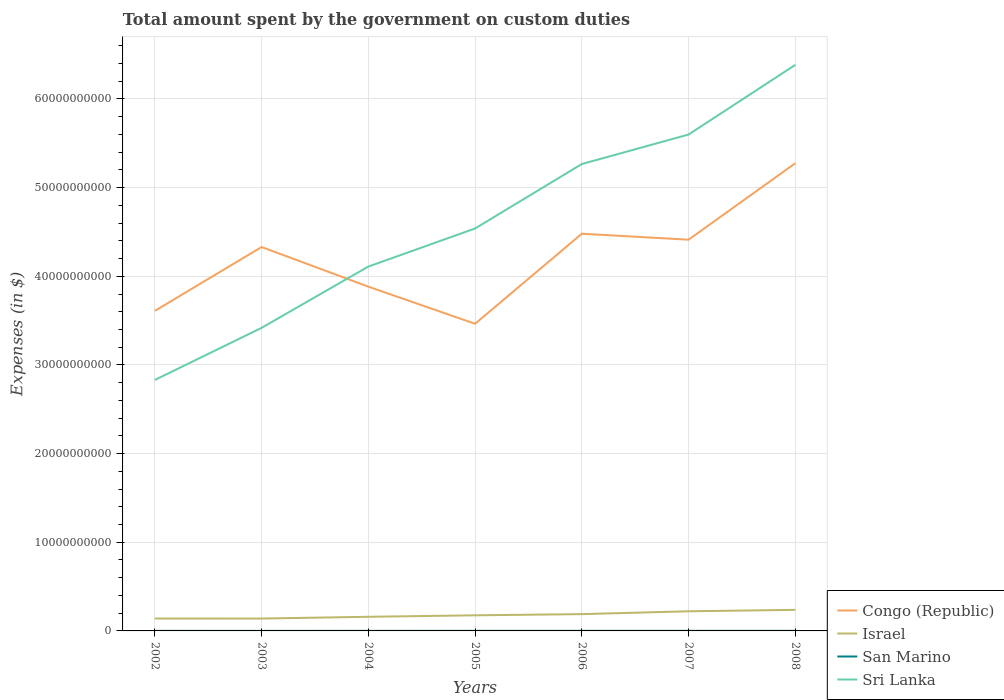How many different coloured lines are there?
Offer a terse response. 4. Across all years, what is the maximum amount spent on custom duties by the government in Israel?
Give a very brief answer. 1.39e+09. What is the total amount spent on custom duties by the government in San Marino in the graph?
Provide a short and direct response. -5.59e+05. What is the difference between the highest and the second highest amount spent on custom duties by the government in San Marino?
Your answer should be compact. 6.27e+06. Is the amount spent on custom duties by the government in San Marino strictly greater than the amount spent on custom duties by the government in Sri Lanka over the years?
Keep it short and to the point. Yes. How many years are there in the graph?
Offer a very short reply. 7. What is the difference between two consecutive major ticks on the Y-axis?
Provide a short and direct response. 1.00e+1. How are the legend labels stacked?
Provide a short and direct response. Vertical. What is the title of the graph?
Provide a succinct answer. Total amount spent by the government on custom duties. Does "Macedonia" appear as one of the legend labels in the graph?
Your response must be concise. No. What is the label or title of the Y-axis?
Provide a short and direct response. Expenses (in $). What is the Expenses (in $) of Congo (Republic) in 2002?
Ensure brevity in your answer.  3.61e+1. What is the Expenses (in $) of Israel in 2002?
Your answer should be very brief. 1.40e+09. What is the Expenses (in $) in San Marino in 2002?
Offer a very short reply. 4.43e+06. What is the Expenses (in $) in Sri Lanka in 2002?
Keep it short and to the point. 2.83e+1. What is the Expenses (in $) of Congo (Republic) in 2003?
Offer a terse response. 4.33e+1. What is the Expenses (in $) in Israel in 2003?
Give a very brief answer. 1.39e+09. What is the Expenses (in $) in San Marino in 2003?
Your response must be concise. 3.79e+06. What is the Expenses (in $) of Sri Lanka in 2003?
Keep it short and to the point. 3.42e+1. What is the Expenses (in $) of Congo (Republic) in 2004?
Make the answer very short. 3.88e+1. What is the Expenses (in $) of Israel in 2004?
Provide a succinct answer. 1.59e+09. What is the Expenses (in $) of San Marino in 2004?
Ensure brevity in your answer.  5.95e+06. What is the Expenses (in $) in Sri Lanka in 2004?
Provide a short and direct response. 4.11e+1. What is the Expenses (in $) in Congo (Republic) in 2005?
Your answer should be compact. 3.46e+1. What is the Expenses (in $) in Israel in 2005?
Offer a terse response. 1.76e+09. What is the Expenses (in $) in San Marino in 2005?
Offer a very short reply. 8.54e+06. What is the Expenses (in $) of Sri Lanka in 2005?
Offer a very short reply. 4.54e+1. What is the Expenses (in $) of Congo (Republic) in 2006?
Provide a succinct answer. 4.48e+1. What is the Expenses (in $) in Israel in 2006?
Make the answer very short. 1.89e+09. What is the Expenses (in $) in San Marino in 2006?
Your response must be concise. 1.01e+07. What is the Expenses (in $) in Sri Lanka in 2006?
Provide a short and direct response. 5.27e+1. What is the Expenses (in $) of Congo (Republic) in 2007?
Offer a terse response. 4.41e+1. What is the Expenses (in $) of Israel in 2007?
Your answer should be very brief. 2.22e+09. What is the Expenses (in $) of San Marino in 2007?
Provide a short and direct response. 9.10e+06. What is the Expenses (in $) of Sri Lanka in 2007?
Your answer should be very brief. 5.60e+1. What is the Expenses (in $) in Congo (Republic) in 2008?
Offer a terse response. 5.27e+1. What is the Expenses (in $) in Israel in 2008?
Give a very brief answer. 2.38e+09. What is the Expenses (in $) in San Marino in 2008?
Ensure brevity in your answer.  9.16e+06. What is the Expenses (in $) in Sri Lanka in 2008?
Give a very brief answer. 6.38e+1. Across all years, what is the maximum Expenses (in $) in Congo (Republic)?
Your answer should be very brief. 5.27e+1. Across all years, what is the maximum Expenses (in $) in Israel?
Make the answer very short. 2.38e+09. Across all years, what is the maximum Expenses (in $) in San Marino?
Provide a short and direct response. 1.01e+07. Across all years, what is the maximum Expenses (in $) of Sri Lanka?
Offer a very short reply. 6.38e+1. Across all years, what is the minimum Expenses (in $) in Congo (Republic)?
Your response must be concise. 3.46e+1. Across all years, what is the minimum Expenses (in $) in Israel?
Offer a very short reply. 1.39e+09. Across all years, what is the minimum Expenses (in $) of San Marino?
Your answer should be very brief. 3.79e+06. Across all years, what is the minimum Expenses (in $) of Sri Lanka?
Ensure brevity in your answer.  2.83e+1. What is the total Expenses (in $) in Congo (Republic) in the graph?
Make the answer very short. 2.95e+11. What is the total Expenses (in $) of Israel in the graph?
Offer a terse response. 1.26e+1. What is the total Expenses (in $) of San Marino in the graph?
Offer a terse response. 5.10e+07. What is the total Expenses (in $) in Sri Lanka in the graph?
Offer a very short reply. 3.21e+11. What is the difference between the Expenses (in $) in Congo (Republic) in 2002 and that in 2003?
Your response must be concise. -7.20e+09. What is the difference between the Expenses (in $) of San Marino in 2002 and that in 2003?
Give a very brief answer. 6.50e+05. What is the difference between the Expenses (in $) of Sri Lanka in 2002 and that in 2003?
Keep it short and to the point. -5.88e+09. What is the difference between the Expenses (in $) of Congo (Republic) in 2002 and that in 2004?
Keep it short and to the point. -2.73e+09. What is the difference between the Expenses (in $) in Israel in 2002 and that in 2004?
Ensure brevity in your answer.  -1.96e+08. What is the difference between the Expenses (in $) of San Marino in 2002 and that in 2004?
Make the answer very short. -1.52e+06. What is the difference between the Expenses (in $) of Sri Lanka in 2002 and that in 2004?
Your response must be concise. -1.28e+1. What is the difference between the Expenses (in $) in Congo (Republic) in 2002 and that in 2005?
Your answer should be very brief. 1.46e+09. What is the difference between the Expenses (in $) of Israel in 2002 and that in 2005?
Ensure brevity in your answer.  -3.63e+08. What is the difference between the Expenses (in $) of San Marino in 2002 and that in 2005?
Your response must be concise. -4.10e+06. What is the difference between the Expenses (in $) in Sri Lanka in 2002 and that in 2005?
Make the answer very short. -1.71e+1. What is the difference between the Expenses (in $) of Congo (Republic) in 2002 and that in 2006?
Offer a very short reply. -8.70e+09. What is the difference between the Expenses (in $) of Israel in 2002 and that in 2006?
Provide a succinct answer. -4.96e+08. What is the difference between the Expenses (in $) of San Marino in 2002 and that in 2006?
Provide a short and direct response. -5.62e+06. What is the difference between the Expenses (in $) in Sri Lanka in 2002 and that in 2006?
Give a very brief answer. -2.44e+1. What is the difference between the Expenses (in $) in Congo (Republic) in 2002 and that in 2007?
Your answer should be very brief. -8.03e+09. What is the difference between the Expenses (in $) in Israel in 2002 and that in 2007?
Your answer should be compact. -8.17e+08. What is the difference between the Expenses (in $) in San Marino in 2002 and that in 2007?
Make the answer very short. -4.66e+06. What is the difference between the Expenses (in $) of Sri Lanka in 2002 and that in 2007?
Give a very brief answer. -2.77e+1. What is the difference between the Expenses (in $) in Congo (Republic) in 2002 and that in 2008?
Keep it short and to the point. -1.66e+1. What is the difference between the Expenses (in $) of Israel in 2002 and that in 2008?
Your answer should be very brief. -9.77e+08. What is the difference between the Expenses (in $) in San Marino in 2002 and that in 2008?
Give a very brief answer. -4.73e+06. What is the difference between the Expenses (in $) in Sri Lanka in 2002 and that in 2008?
Offer a very short reply. -3.55e+1. What is the difference between the Expenses (in $) of Congo (Republic) in 2003 and that in 2004?
Your answer should be very brief. 4.47e+09. What is the difference between the Expenses (in $) of Israel in 2003 and that in 2004?
Your response must be concise. -2.00e+08. What is the difference between the Expenses (in $) of San Marino in 2003 and that in 2004?
Ensure brevity in your answer.  -2.17e+06. What is the difference between the Expenses (in $) of Sri Lanka in 2003 and that in 2004?
Make the answer very short. -6.91e+09. What is the difference between the Expenses (in $) in Congo (Republic) in 2003 and that in 2005?
Provide a succinct answer. 8.66e+09. What is the difference between the Expenses (in $) of Israel in 2003 and that in 2005?
Your answer should be compact. -3.67e+08. What is the difference between the Expenses (in $) in San Marino in 2003 and that in 2005?
Ensure brevity in your answer.  -4.75e+06. What is the difference between the Expenses (in $) in Sri Lanka in 2003 and that in 2005?
Your answer should be very brief. -1.12e+1. What is the difference between the Expenses (in $) of Congo (Republic) in 2003 and that in 2006?
Provide a short and direct response. -1.50e+09. What is the difference between the Expenses (in $) in Israel in 2003 and that in 2006?
Provide a succinct answer. -5.00e+08. What is the difference between the Expenses (in $) of San Marino in 2003 and that in 2006?
Give a very brief answer. -6.27e+06. What is the difference between the Expenses (in $) of Sri Lanka in 2003 and that in 2006?
Make the answer very short. -1.85e+1. What is the difference between the Expenses (in $) in Congo (Republic) in 2003 and that in 2007?
Provide a short and direct response. -8.27e+08. What is the difference between the Expenses (in $) of Israel in 2003 and that in 2007?
Provide a short and direct response. -8.21e+08. What is the difference between the Expenses (in $) of San Marino in 2003 and that in 2007?
Your response must be concise. -5.31e+06. What is the difference between the Expenses (in $) in Sri Lanka in 2003 and that in 2007?
Ensure brevity in your answer.  -2.18e+1. What is the difference between the Expenses (in $) of Congo (Republic) in 2003 and that in 2008?
Your answer should be compact. -9.45e+09. What is the difference between the Expenses (in $) of Israel in 2003 and that in 2008?
Provide a short and direct response. -9.81e+08. What is the difference between the Expenses (in $) of San Marino in 2003 and that in 2008?
Offer a very short reply. -5.38e+06. What is the difference between the Expenses (in $) of Sri Lanka in 2003 and that in 2008?
Your response must be concise. -2.97e+1. What is the difference between the Expenses (in $) in Congo (Republic) in 2004 and that in 2005?
Your answer should be compact. 4.19e+09. What is the difference between the Expenses (in $) of Israel in 2004 and that in 2005?
Keep it short and to the point. -1.67e+08. What is the difference between the Expenses (in $) of San Marino in 2004 and that in 2005?
Make the answer very short. -2.58e+06. What is the difference between the Expenses (in $) in Sri Lanka in 2004 and that in 2005?
Give a very brief answer. -4.29e+09. What is the difference between the Expenses (in $) in Congo (Republic) in 2004 and that in 2006?
Provide a succinct answer. -5.97e+09. What is the difference between the Expenses (in $) in Israel in 2004 and that in 2006?
Make the answer very short. -3.00e+08. What is the difference between the Expenses (in $) in San Marino in 2004 and that in 2006?
Give a very brief answer. -4.10e+06. What is the difference between the Expenses (in $) in Sri Lanka in 2004 and that in 2006?
Provide a succinct answer. -1.16e+1. What is the difference between the Expenses (in $) of Congo (Republic) in 2004 and that in 2007?
Make the answer very short. -5.30e+09. What is the difference between the Expenses (in $) in Israel in 2004 and that in 2007?
Keep it short and to the point. -6.21e+08. What is the difference between the Expenses (in $) in San Marino in 2004 and that in 2007?
Your answer should be very brief. -3.14e+06. What is the difference between the Expenses (in $) of Sri Lanka in 2004 and that in 2007?
Your answer should be compact. -1.49e+1. What is the difference between the Expenses (in $) in Congo (Republic) in 2004 and that in 2008?
Offer a very short reply. -1.39e+1. What is the difference between the Expenses (in $) of Israel in 2004 and that in 2008?
Give a very brief answer. -7.81e+08. What is the difference between the Expenses (in $) of San Marino in 2004 and that in 2008?
Keep it short and to the point. -3.21e+06. What is the difference between the Expenses (in $) in Sri Lanka in 2004 and that in 2008?
Provide a short and direct response. -2.27e+1. What is the difference between the Expenses (in $) in Congo (Republic) in 2005 and that in 2006?
Your answer should be compact. -1.02e+1. What is the difference between the Expenses (in $) in Israel in 2005 and that in 2006?
Provide a short and direct response. -1.33e+08. What is the difference between the Expenses (in $) in San Marino in 2005 and that in 2006?
Make the answer very short. -1.51e+06. What is the difference between the Expenses (in $) in Sri Lanka in 2005 and that in 2006?
Offer a very short reply. -7.27e+09. What is the difference between the Expenses (in $) of Congo (Republic) in 2005 and that in 2007?
Your answer should be very brief. -9.48e+09. What is the difference between the Expenses (in $) in Israel in 2005 and that in 2007?
Give a very brief answer. -4.54e+08. What is the difference between the Expenses (in $) of San Marino in 2005 and that in 2007?
Your answer should be compact. -5.59e+05. What is the difference between the Expenses (in $) of Sri Lanka in 2005 and that in 2007?
Offer a very short reply. -1.06e+1. What is the difference between the Expenses (in $) of Congo (Republic) in 2005 and that in 2008?
Give a very brief answer. -1.81e+1. What is the difference between the Expenses (in $) in Israel in 2005 and that in 2008?
Your response must be concise. -6.14e+08. What is the difference between the Expenses (in $) in San Marino in 2005 and that in 2008?
Your answer should be compact. -6.25e+05. What is the difference between the Expenses (in $) in Sri Lanka in 2005 and that in 2008?
Offer a very short reply. -1.85e+1. What is the difference between the Expenses (in $) in Congo (Republic) in 2006 and that in 2007?
Keep it short and to the point. 6.73e+08. What is the difference between the Expenses (in $) of Israel in 2006 and that in 2007?
Keep it short and to the point. -3.21e+08. What is the difference between the Expenses (in $) in San Marino in 2006 and that in 2007?
Your answer should be compact. 9.55e+05. What is the difference between the Expenses (in $) of Sri Lanka in 2006 and that in 2007?
Keep it short and to the point. -3.33e+09. What is the difference between the Expenses (in $) in Congo (Republic) in 2006 and that in 2008?
Your response must be concise. -7.95e+09. What is the difference between the Expenses (in $) of Israel in 2006 and that in 2008?
Provide a short and direct response. -4.81e+08. What is the difference between the Expenses (in $) in San Marino in 2006 and that in 2008?
Make the answer very short. 8.89e+05. What is the difference between the Expenses (in $) of Sri Lanka in 2006 and that in 2008?
Your answer should be compact. -1.12e+1. What is the difference between the Expenses (in $) in Congo (Republic) in 2007 and that in 2008?
Your response must be concise. -8.62e+09. What is the difference between the Expenses (in $) of Israel in 2007 and that in 2008?
Give a very brief answer. -1.60e+08. What is the difference between the Expenses (in $) in San Marino in 2007 and that in 2008?
Give a very brief answer. -6.51e+04. What is the difference between the Expenses (in $) in Sri Lanka in 2007 and that in 2008?
Provide a short and direct response. -7.86e+09. What is the difference between the Expenses (in $) of Congo (Republic) in 2002 and the Expenses (in $) of Israel in 2003?
Provide a short and direct response. 3.47e+1. What is the difference between the Expenses (in $) of Congo (Republic) in 2002 and the Expenses (in $) of San Marino in 2003?
Your response must be concise. 3.61e+1. What is the difference between the Expenses (in $) in Congo (Republic) in 2002 and the Expenses (in $) in Sri Lanka in 2003?
Your response must be concise. 1.92e+09. What is the difference between the Expenses (in $) in Israel in 2002 and the Expenses (in $) in San Marino in 2003?
Your answer should be very brief. 1.39e+09. What is the difference between the Expenses (in $) in Israel in 2002 and the Expenses (in $) in Sri Lanka in 2003?
Your answer should be compact. -3.28e+1. What is the difference between the Expenses (in $) in San Marino in 2002 and the Expenses (in $) in Sri Lanka in 2003?
Ensure brevity in your answer.  -3.42e+1. What is the difference between the Expenses (in $) in Congo (Republic) in 2002 and the Expenses (in $) in Israel in 2004?
Give a very brief answer. 3.45e+1. What is the difference between the Expenses (in $) of Congo (Republic) in 2002 and the Expenses (in $) of San Marino in 2004?
Offer a very short reply. 3.61e+1. What is the difference between the Expenses (in $) of Congo (Republic) in 2002 and the Expenses (in $) of Sri Lanka in 2004?
Give a very brief answer. -5.00e+09. What is the difference between the Expenses (in $) in Israel in 2002 and the Expenses (in $) in San Marino in 2004?
Offer a very short reply. 1.39e+09. What is the difference between the Expenses (in $) of Israel in 2002 and the Expenses (in $) of Sri Lanka in 2004?
Provide a short and direct response. -3.97e+1. What is the difference between the Expenses (in $) of San Marino in 2002 and the Expenses (in $) of Sri Lanka in 2004?
Ensure brevity in your answer.  -4.11e+1. What is the difference between the Expenses (in $) in Congo (Republic) in 2002 and the Expenses (in $) in Israel in 2005?
Provide a succinct answer. 3.43e+1. What is the difference between the Expenses (in $) of Congo (Republic) in 2002 and the Expenses (in $) of San Marino in 2005?
Provide a succinct answer. 3.61e+1. What is the difference between the Expenses (in $) in Congo (Republic) in 2002 and the Expenses (in $) in Sri Lanka in 2005?
Give a very brief answer. -9.29e+09. What is the difference between the Expenses (in $) of Israel in 2002 and the Expenses (in $) of San Marino in 2005?
Offer a very short reply. 1.39e+09. What is the difference between the Expenses (in $) in Israel in 2002 and the Expenses (in $) in Sri Lanka in 2005?
Your answer should be very brief. -4.40e+1. What is the difference between the Expenses (in $) in San Marino in 2002 and the Expenses (in $) in Sri Lanka in 2005?
Your response must be concise. -4.54e+1. What is the difference between the Expenses (in $) of Congo (Republic) in 2002 and the Expenses (in $) of Israel in 2006?
Ensure brevity in your answer.  3.42e+1. What is the difference between the Expenses (in $) of Congo (Republic) in 2002 and the Expenses (in $) of San Marino in 2006?
Provide a succinct answer. 3.61e+1. What is the difference between the Expenses (in $) of Congo (Republic) in 2002 and the Expenses (in $) of Sri Lanka in 2006?
Provide a succinct answer. -1.66e+1. What is the difference between the Expenses (in $) of Israel in 2002 and the Expenses (in $) of San Marino in 2006?
Offer a terse response. 1.39e+09. What is the difference between the Expenses (in $) of Israel in 2002 and the Expenses (in $) of Sri Lanka in 2006?
Offer a very short reply. -5.13e+1. What is the difference between the Expenses (in $) in San Marino in 2002 and the Expenses (in $) in Sri Lanka in 2006?
Provide a short and direct response. -5.27e+1. What is the difference between the Expenses (in $) of Congo (Republic) in 2002 and the Expenses (in $) of Israel in 2007?
Offer a very short reply. 3.39e+1. What is the difference between the Expenses (in $) in Congo (Republic) in 2002 and the Expenses (in $) in San Marino in 2007?
Your answer should be very brief. 3.61e+1. What is the difference between the Expenses (in $) of Congo (Republic) in 2002 and the Expenses (in $) of Sri Lanka in 2007?
Make the answer very short. -1.99e+1. What is the difference between the Expenses (in $) in Israel in 2002 and the Expenses (in $) in San Marino in 2007?
Provide a succinct answer. 1.39e+09. What is the difference between the Expenses (in $) in Israel in 2002 and the Expenses (in $) in Sri Lanka in 2007?
Your answer should be very brief. -5.46e+1. What is the difference between the Expenses (in $) of San Marino in 2002 and the Expenses (in $) of Sri Lanka in 2007?
Offer a terse response. -5.60e+1. What is the difference between the Expenses (in $) of Congo (Republic) in 2002 and the Expenses (in $) of Israel in 2008?
Your answer should be compact. 3.37e+1. What is the difference between the Expenses (in $) in Congo (Republic) in 2002 and the Expenses (in $) in San Marino in 2008?
Your response must be concise. 3.61e+1. What is the difference between the Expenses (in $) of Congo (Republic) in 2002 and the Expenses (in $) of Sri Lanka in 2008?
Offer a very short reply. -2.77e+1. What is the difference between the Expenses (in $) of Israel in 2002 and the Expenses (in $) of San Marino in 2008?
Your answer should be compact. 1.39e+09. What is the difference between the Expenses (in $) of Israel in 2002 and the Expenses (in $) of Sri Lanka in 2008?
Ensure brevity in your answer.  -6.24e+1. What is the difference between the Expenses (in $) in San Marino in 2002 and the Expenses (in $) in Sri Lanka in 2008?
Ensure brevity in your answer.  -6.38e+1. What is the difference between the Expenses (in $) in Congo (Republic) in 2003 and the Expenses (in $) in Israel in 2004?
Give a very brief answer. 4.17e+1. What is the difference between the Expenses (in $) in Congo (Republic) in 2003 and the Expenses (in $) in San Marino in 2004?
Your answer should be compact. 4.33e+1. What is the difference between the Expenses (in $) of Congo (Republic) in 2003 and the Expenses (in $) of Sri Lanka in 2004?
Your answer should be very brief. 2.20e+09. What is the difference between the Expenses (in $) in Israel in 2003 and the Expenses (in $) in San Marino in 2004?
Give a very brief answer. 1.39e+09. What is the difference between the Expenses (in $) of Israel in 2003 and the Expenses (in $) of Sri Lanka in 2004?
Offer a very short reply. -3.97e+1. What is the difference between the Expenses (in $) of San Marino in 2003 and the Expenses (in $) of Sri Lanka in 2004?
Provide a short and direct response. -4.11e+1. What is the difference between the Expenses (in $) of Congo (Republic) in 2003 and the Expenses (in $) of Israel in 2005?
Your response must be concise. 4.15e+1. What is the difference between the Expenses (in $) of Congo (Republic) in 2003 and the Expenses (in $) of San Marino in 2005?
Give a very brief answer. 4.33e+1. What is the difference between the Expenses (in $) of Congo (Republic) in 2003 and the Expenses (in $) of Sri Lanka in 2005?
Offer a very short reply. -2.09e+09. What is the difference between the Expenses (in $) in Israel in 2003 and the Expenses (in $) in San Marino in 2005?
Give a very brief answer. 1.39e+09. What is the difference between the Expenses (in $) in Israel in 2003 and the Expenses (in $) in Sri Lanka in 2005?
Provide a short and direct response. -4.40e+1. What is the difference between the Expenses (in $) of San Marino in 2003 and the Expenses (in $) of Sri Lanka in 2005?
Provide a succinct answer. -4.54e+1. What is the difference between the Expenses (in $) of Congo (Republic) in 2003 and the Expenses (in $) of Israel in 2006?
Make the answer very short. 4.14e+1. What is the difference between the Expenses (in $) in Congo (Republic) in 2003 and the Expenses (in $) in San Marino in 2006?
Your answer should be very brief. 4.33e+1. What is the difference between the Expenses (in $) of Congo (Republic) in 2003 and the Expenses (in $) of Sri Lanka in 2006?
Provide a succinct answer. -9.36e+09. What is the difference between the Expenses (in $) of Israel in 2003 and the Expenses (in $) of San Marino in 2006?
Your answer should be compact. 1.38e+09. What is the difference between the Expenses (in $) in Israel in 2003 and the Expenses (in $) in Sri Lanka in 2006?
Offer a very short reply. -5.13e+1. What is the difference between the Expenses (in $) of San Marino in 2003 and the Expenses (in $) of Sri Lanka in 2006?
Provide a succinct answer. -5.27e+1. What is the difference between the Expenses (in $) in Congo (Republic) in 2003 and the Expenses (in $) in Israel in 2007?
Offer a terse response. 4.11e+1. What is the difference between the Expenses (in $) of Congo (Republic) in 2003 and the Expenses (in $) of San Marino in 2007?
Offer a terse response. 4.33e+1. What is the difference between the Expenses (in $) in Congo (Republic) in 2003 and the Expenses (in $) in Sri Lanka in 2007?
Provide a short and direct response. -1.27e+1. What is the difference between the Expenses (in $) of Israel in 2003 and the Expenses (in $) of San Marino in 2007?
Offer a very short reply. 1.38e+09. What is the difference between the Expenses (in $) in Israel in 2003 and the Expenses (in $) in Sri Lanka in 2007?
Ensure brevity in your answer.  -5.46e+1. What is the difference between the Expenses (in $) of San Marino in 2003 and the Expenses (in $) of Sri Lanka in 2007?
Offer a very short reply. -5.60e+1. What is the difference between the Expenses (in $) in Congo (Republic) in 2003 and the Expenses (in $) in Israel in 2008?
Your answer should be very brief. 4.09e+1. What is the difference between the Expenses (in $) in Congo (Republic) in 2003 and the Expenses (in $) in San Marino in 2008?
Offer a very short reply. 4.33e+1. What is the difference between the Expenses (in $) in Congo (Republic) in 2003 and the Expenses (in $) in Sri Lanka in 2008?
Your answer should be very brief. -2.05e+1. What is the difference between the Expenses (in $) in Israel in 2003 and the Expenses (in $) in San Marino in 2008?
Your answer should be compact. 1.38e+09. What is the difference between the Expenses (in $) of Israel in 2003 and the Expenses (in $) of Sri Lanka in 2008?
Your answer should be very brief. -6.24e+1. What is the difference between the Expenses (in $) in San Marino in 2003 and the Expenses (in $) in Sri Lanka in 2008?
Keep it short and to the point. -6.38e+1. What is the difference between the Expenses (in $) of Congo (Republic) in 2004 and the Expenses (in $) of Israel in 2005?
Keep it short and to the point. 3.71e+1. What is the difference between the Expenses (in $) of Congo (Republic) in 2004 and the Expenses (in $) of San Marino in 2005?
Ensure brevity in your answer.  3.88e+1. What is the difference between the Expenses (in $) of Congo (Republic) in 2004 and the Expenses (in $) of Sri Lanka in 2005?
Make the answer very short. -6.56e+09. What is the difference between the Expenses (in $) of Israel in 2004 and the Expenses (in $) of San Marino in 2005?
Provide a succinct answer. 1.59e+09. What is the difference between the Expenses (in $) of Israel in 2004 and the Expenses (in $) of Sri Lanka in 2005?
Make the answer very short. -4.38e+1. What is the difference between the Expenses (in $) in San Marino in 2004 and the Expenses (in $) in Sri Lanka in 2005?
Your answer should be compact. -4.54e+1. What is the difference between the Expenses (in $) in Congo (Republic) in 2004 and the Expenses (in $) in Israel in 2006?
Provide a succinct answer. 3.69e+1. What is the difference between the Expenses (in $) of Congo (Republic) in 2004 and the Expenses (in $) of San Marino in 2006?
Provide a succinct answer. 3.88e+1. What is the difference between the Expenses (in $) in Congo (Republic) in 2004 and the Expenses (in $) in Sri Lanka in 2006?
Provide a succinct answer. -1.38e+1. What is the difference between the Expenses (in $) in Israel in 2004 and the Expenses (in $) in San Marino in 2006?
Keep it short and to the point. 1.58e+09. What is the difference between the Expenses (in $) in Israel in 2004 and the Expenses (in $) in Sri Lanka in 2006?
Your response must be concise. -5.11e+1. What is the difference between the Expenses (in $) of San Marino in 2004 and the Expenses (in $) of Sri Lanka in 2006?
Offer a terse response. -5.27e+1. What is the difference between the Expenses (in $) of Congo (Republic) in 2004 and the Expenses (in $) of Israel in 2007?
Your answer should be very brief. 3.66e+1. What is the difference between the Expenses (in $) in Congo (Republic) in 2004 and the Expenses (in $) in San Marino in 2007?
Keep it short and to the point. 3.88e+1. What is the difference between the Expenses (in $) of Congo (Republic) in 2004 and the Expenses (in $) of Sri Lanka in 2007?
Ensure brevity in your answer.  -1.72e+1. What is the difference between the Expenses (in $) in Israel in 2004 and the Expenses (in $) in San Marino in 2007?
Give a very brief answer. 1.58e+09. What is the difference between the Expenses (in $) of Israel in 2004 and the Expenses (in $) of Sri Lanka in 2007?
Ensure brevity in your answer.  -5.44e+1. What is the difference between the Expenses (in $) in San Marino in 2004 and the Expenses (in $) in Sri Lanka in 2007?
Offer a terse response. -5.60e+1. What is the difference between the Expenses (in $) of Congo (Republic) in 2004 and the Expenses (in $) of Israel in 2008?
Provide a short and direct response. 3.65e+1. What is the difference between the Expenses (in $) of Congo (Republic) in 2004 and the Expenses (in $) of San Marino in 2008?
Offer a very short reply. 3.88e+1. What is the difference between the Expenses (in $) of Congo (Republic) in 2004 and the Expenses (in $) of Sri Lanka in 2008?
Your answer should be very brief. -2.50e+1. What is the difference between the Expenses (in $) of Israel in 2004 and the Expenses (in $) of San Marino in 2008?
Give a very brief answer. 1.58e+09. What is the difference between the Expenses (in $) of Israel in 2004 and the Expenses (in $) of Sri Lanka in 2008?
Give a very brief answer. -6.22e+1. What is the difference between the Expenses (in $) of San Marino in 2004 and the Expenses (in $) of Sri Lanka in 2008?
Ensure brevity in your answer.  -6.38e+1. What is the difference between the Expenses (in $) of Congo (Republic) in 2005 and the Expenses (in $) of Israel in 2006?
Your response must be concise. 3.27e+1. What is the difference between the Expenses (in $) of Congo (Republic) in 2005 and the Expenses (in $) of San Marino in 2006?
Keep it short and to the point. 3.46e+1. What is the difference between the Expenses (in $) in Congo (Republic) in 2005 and the Expenses (in $) in Sri Lanka in 2006?
Provide a succinct answer. -1.80e+1. What is the difference between the Expenses (in $) of Israel in 2005 and the Expenses (in $) of San Marino in 2006?
Offer a terse response. 1.75e+09. What is the difference between the Expenses (in $) in Israel in 2005 and the Expenses (in $) in Sri Lanka in 2006?
Offer a terse response. -5.09e+1. What is the difference between the Expenses (in $) of San Marino in 2005 and the Expenses (in $) of Sri Lanka in 2006?
Your response must be concise. -5.27e+1. What is the difference between the Expenses (in $) of Congo (Republic) in 2005 and the Expenses (in $) of Israel in 2007?
Ensure brevity in your answer.  3.24e+1. What is the difference between the Expenses (in $) in Congo (Republic) in 2005 and the Expenses (in $) in San Marino in 2007?
Give a very brief answer. 3.46e+1. What is the difference between the Expenses (in $) in Congo (Republic) in 2005 and the Expenses (in $) in Sri Lanka in 2007?
Give a very brief answer. -2.13e+1. What is the difference between the Expenses (in $) in Israel in 2005 and the Expenses (in $) in San Marino in 2007?
Your response must be concise. 1.75e+09. What is the difference between the Expenses (in $) of Israel in 2005 and the Expenses (in $) of Sri Lanka in 2007?
Make the answer very short. -5.42e+1. What is the difference between the Expenses (in $) in San Marino in 2005 and the Expenses (in $) in Sri Lanka in 2007?
Your answer should be compact. -5.60e+1. What is the difference between the Expenses (in $) in Congo (Republic) in 2005 and the Expenses (in $) in Israel in 2008?
Provide a succinct answer. 3.23e+1. What is the difference between the Expenses (in $) of Congo (Republic) in 2005 and the Expenses (in $) of San Marino in 2008?
Offer a terse response. 3.46e+1. What is the difference between the Expenses (in $) in Congo (Republic) in 2005 and the Expenses (in $) in Sri Lanka in 2008?
Offer a terse response. -2.92e+1. What is the difference between the Expenses (in $) of Israel in 2005 and the Expenses (in $) of San Marino in 2008?
Offer a very short reply. 1.75e+09. What is the difference between the Expenses (in $) in Israel in 2005 and the Expenses (in $) in Sri Lanka in 2008?
Ensure brevity in your answer.  -6.21e+1. What is the difference between the Expenses (in $) of San Marino in 2005 and the Expenses (in $) of Sri Lanka in 2008?
Give a very brief answer. -6.38e+1. What is the difference between the Expenses (in $) in Congo (Republic) in 2006 and the Expenses (in $) in Israel in 2007?
Keep it short and to the point. 4.26e+1. What is the difference between the Expenses (in $) in Congo (Republic) in 2006 and the Expenses (in $) in San Marino in 2007?
Ensure brevity in your answer.  4.48e+1. What is the difference between the Expenses (in $) of Congo (Republic) in 2006 and the Expenses (in $) of Sri Lanka in 2007?
Your response must be concise. -1.12e+1. What is the difference between the Expenses (in $) in Israel in 2006 and the Expenses (in $) in San Marino in 2007?
Your response must be concise. 1.88e+09. What is the difference between the Expenses (in $) of Israel in 2006 and the Expenses (in $) of Sri Lanka in 2007?
Offer a terse response. -5.41e+1. What is the difference between the Expenses (in $) in San Marino in 2006 and the Expenses (in $) in Sri Lanka in 2007?
Keep it short and to the point. -5.60e+1. What is the difference between the Expenses (in $) of Congo (Republic) in 2006 and the Expenses (in $) of Israel in 2008?
Provide a succinct answer. 4.24e+1. What is the difference between the Expenses (in $) of Congo (Republic) in 2006 and the Expenses (in $) of San Marino in 2008?
Keep it short and to the point. 4.48e+1. What is the difference between the Expenses (in $) of Congo (Republic) in 2006 and the Expenses (in $) of Sri Lanka in 2008?
Ensure brevity in your answer.  -1.90e+1. What is the difference between the Expenses (in $) of Israel in 2006 and the Expenses (in $) of San Marino in 2008?
Provide a succinct answer. 1.88e+09. What is the difference between the Expenses (in $) in Israel in 2006 and the Expenses (in $) in Sri Lanka in 2008?
Provide a short and direct response. -6.20e+1. What is the difference between the Expenses (in $) of San Marino in 2006 and the Expenses (in $) of Sri Lanka in 2008?
Your answer should be compact. -6.38e+1. What is the difference between the Expenses (in $) in Congo (Republic) in 2007 and the Expenses (in $) in Israel in 2008?
Offer a terse response. 4.18e+1. What is the difference between the Expenses (in $) in Congo (Republic) in 2007 and the Expenses (in $) in San Marino in 2008?
Your response must be concise. 4.41e+1. What is the difference between the Expenses (in $) in Congo (Republic) in 2007 and the Expenses (in $) in Sri Lanka in 2008?
Give a very brief answer. -1.97e+1. What is the difference between the Expenses (in $) of Israel in 2007 and the Expenses (in $) of San Marino in 2008?
Provide a short and direct response. 2.21e+09. What is the difference between the Expenses (in $) of Israel in 2007 and the Expenses (in $) of Sri Lanka in 2008?
Your answer should be very brief. -6.16e+1. What is the difference between the Expenses (in $) of San Marino in 2007 and the Expenses (in $) of Sri Lanka in 2008?
Provide a short and direct response. -6.38e+1. What is the average Expenses (in $) in Congo (Republic) per year?
Make the answer very short. 4.21e+1. What is the average Expenses (in $) in Israel per year?
Make the answer very short. 1.80e+09. What is the average Expenses (in $) of San Marino per year?
Make the answer very short. 7.29e+06. What is the average Expenses (in $) in Sri Lanka per year?
Give a very brief answer. 4.59e+1. In the year 2002, what is the difference between the Expenses (in $) in Congo (Republic) and Expenses (in $) in Israel?
Offer a terse response. 3.47e+1. In the year 2002, what is the difference between the Expenses (in $) in Congo (Republic) and Expenses (in $) in San Marino?
Provide a succinct answer. 3.61e+1. In the year 2002, what is the difference between the Expenses (in $) in Congo (Republic) and Expenses (in $) in Sri Lanka?
Provide a short and direct response. 7.79e+09. In the year 2002, what is the difference between the Expenses (in $) in Israel and Expenses (in $) in San Marino?
Your answer should be compact. 1.39e+09. In the year 2002, what is the difference between the Expenses (in $) of Israel and Expenses (in $) of Sri Lanka?
Offer a very short reply. -2.69e+1. In the year 2002, what is the difference between the Expenses (in $) in San Marino and Expenses (in $) in Sri Lanka?
Your answer should be compact. -2.83e+1. In the year 2003, what is the difference between the Expenses (in $) of Congo (Republic) and Expenses (in $) of Israel?
Your answer should be very brief. 4.19e+1. In the year 2003, what is the difference between the Expenses (in $) of Congo (Republic) and Expenses (in $) of San Marino?
Your answer should be compact. 4.33e+1. In the year 2003, what is the difference between the Expenses (in $) in Congo (Republic) and Expenses (in $) in Sri Lanka?
Make the answer very short. 9.12e+09. In the year 2003, what is the difference between the Expenses (in $) of Israel and Expenses (in $) of San Marino?
Your answer should be compact. 1.39e+09. In the year 2003, what is the difference between the Expenses (in $) in Israel and Expenses (in $) in Sri Lanka?
Make the answer very short. -3.28e+1. In the year 2003, what is the difference between the Expenses (in $) in San Marino and Expenses (in $) in Sri Lanka?
Provide a succinct answer. -3.42e+1. In the year 2004, what is the difference between the Expenses (in $) of Congo (Republic) and Expenses (in $) of Israel?
Ensure brevity in your answer.  3.72e+1. In the year 2004, what is the difference between the Expenses (in $) in Congo (Republic) and Expenses (in $) in San Marino?
Your answer should be very brief. 3.88e+1. In the year 2004, what is the difference between the Expenses (in $) of Congo (Republic) and Expenses (in $) of Sri Lanka?
Provide a short and direct response. -2.27e+09. In the year 2004, what is the difference between the Expenses (in $) of Israel and Expenses (in $) of San Marino?
Ensure brevity in your answer.  1.59e+09. In the year 2004, what is the difference between the Expenses (in $) in Israel and Expenses (in $) in Sri Lanka?
Offer a very short reply. -3.95e+1. In the year 2004, what is the difference between the Expenses (in $) of San Marino and Expenses (in $) of Sri Lanka?
Provide a short and direct response. -4.11e+1. In the year 2005, what is the difference between the Expenses (in $) of Congo (Republic) and Expenses (in $) of Israel?
Your answer should be very brief. 3.29e+1. In the year 2005, what is the difference between the Expenses (in $) of Congo (Republic) and Expenses (in $) of San Marino?
Your answer should be compact. 3.46e+1. In the year 2005, what is the difference between the Expenses (in $) of Congo (Republic) and Expenses (in $) of Sri Lanka?
Your answer should be compact. -1.07e+1. In the year 2005, what is the difference between the Expenses (in $) in Israel and Expenses (in $) in San Marino?
Your answer should be compact. 1.75e+09. In the year 2005, what is the difference between the Expenses (in $) of Israel and Expenses (in $) of Sri Lanka?
Offer a very short reply. -4.36e+1. In the year 2005, what is the difference between the Expenses (in $) in San Marino and Expenses (in $) in Sri Lanka?
Your answer should be very brief. -4.54e+1. In the year 2006, what is the difference between the Expenses (in $) in Congo (Republic) and Expenses (in $) in Israel?
Provide a short and direct response. 4.29e+1. In the year 2006, what is the difference between the Expenses (in $) in Congo (Republic) and Expenses (in $) in San Marino?
Ensure brevity in your answer.  4.48e+1. In the year 2006, what is the difference between the Expenses (in $) in Congo (Republic) and Expenses (in $) in Sri Lanka?
Offer a terse response. -7.86e+09. In the year 2006, what is the difference between the Expenses (in $) in Israel and Expenses (in $) in San Marino?
Provide a short and direct response. 1.88e+09. In the year 2006, what is the difference between the Expenses (in $) in Israel and Expenses (in $) in Sri Lanka?
Your response must be concise. -5.08e+1. In the year 2006, what is the difference between the Expenses (in $) in San Marino and Expenses (in $) in Sri Lanka?
Your answer should be very brief. -5.27e+1. In the year 2007, what is the difference between the Expenses (in $) in Congo (Republic) and Expenses (in $) in Israel?
Ensure brevity in your answer.  4.19e+1. In the year 2007, what is the difference between the Expenses (in $) of Congo (Republic) and Expenses (in $) of San Marino?
Ensure brevity in your answer.  4.41e+1. In the year 2007, what is the difference between the Expenses (in $) in Congo (Republic) and Expenses (in $) in Sri Lanka?
Provide a succinct answer. -1.19e+1. In the year 2007, what is the difference between the Expenses (in $) of Israel and Expenses (in $) of San Marino?
Provide a short and direct response. 2.21e+09. In the year 2007, what is the difference between the Expenses (in $) in Israel and Expenses (in $) in Sri Lanka?
Provide a short and direct response. -5.38e+1. In the year 2007, what is the difference between the Expenses (in $) of San Marino and Expenses (in $) of Sri Lanka?
Give a very brief answer. -5.60e+1. In the year 2008, what is the difference between the Expenses (in $) in Congo (Republic) and Expenses (in $) in Israel?
Provide a short and direct response. 5.04e+1. In the year 2008, what is the difference between the Expenses (in $) of Congo (Republic) and Expenses (in $) of San Marino?
Keep it short and to the point. 5.27e+1. In the year 2008, what is the difference between the Expenses (in $) of Congo (Republic) and Expenses (in $) of Sri Lanka?
Provide a succinct answer. -1.11e+1. In the year 2008, what is the difference between the Expenses (in $) in Israel and Expenses (in $) in San Marino?
Your response must be concise. 2.37e+09. In the year 2008, what is the difference between the Expenses (in $) of Israel and Expenses (in $) of Sri Lanka?
Ensure brevity in your answer.  -6.15e+1. In the year 2008, what is the difference between the Expenses (in $) of San Marino and Expenses (in $) of Sri Lanka?
Provide a short and direct response. -6.38e+1. What is the ratio of the Expenses (in $) of Congo (Republic) in 2002 to that in 2003?
Offer a terse response. 0.83. What is the ratio of the Expenses (in $) of Israel in 2002 to that in 2003?
Your answer should be very brief. 1. What is the ratio of the Expenses (in $) of San Marino in 2002 to that in 2003?
Provide a succinct answer. 1.17. What is the ratio of the Expenses (in $) of Sri Lanka in 2002 to that in 2003?
Offer a very short reply. 0.83. What is the ratio of the Expenses (in $) in Congo (Republic) in 2002 to that in 2004?
Offer a very short reply. 0.93. What is the ratio of the Expenses (in $) of Israel in 2002 to that in 2004?
Your answer should be very brief. 0.88. What is the ratio of the Expenses (in $) in San Marino in 2002 to that in 2004?
Give a very brief answer. 0.74. What is the ratio of the Expenses (in $) of Sri Lanka in 2002 to that in 2004?
Give a very brief answer. 0.69. What is the ratio of the Expenses (in $) in Congo (Republic) in 2002 to that in 2005?
Provide a short and direct response. 1.04. What is the ratio of the Expenses (in $) of Israel in 2002 to that in 2005?
Offer a terse response. 0.79. What is the ratio of the Expenses (in $) of San Marino in 2002 to that in 2005?
Give a very brief answer. 0.52. What is the ratio of the Expenses (in $) of Sri Lanka in 2002 to that in 2005?
Provide a short and direct response. 0.62. What is the ratio of the Expenses (in $) of Congo (Republic) in 2002 to that in 2006?
Provide a short and direct response. 0.81. What is the ratio of the Expenses (in $) of Israel in 2002 to that in 2006?
Offer a very short reply. 0.74. What is the ratio of the Expenses (in $) in San Marino in 2002 to that in 2006?
Provide a short and direct response. 0.44. What is the ratio of the Expenses (in $) of Sri Lanka in 2002 to that in 2006?
Give a very brief answer. 0.54. What is the ratio of the Expenses (in $) in Congo (Republic) in 2002 to that in 2007?
Your answer should be very brief. 0.82. What is the ratio of the Expenses (in $) of Israel in 2002 to that in 2007?
Your answer should be very brief. 0.63. What is the ratio of the Expenses (in $) in San Marino in 2002 to that in 2007?
Keep it short and to the point. 0.49. What is the ratio of the Expenses (in $) in Sri Lanka in 2002 to that in 2007?
Your answer should be very brief. 0.51. What is the ratio of the Expenses (in $) of Congo (Republic) in 2002 to that in 2008?
Make the answer very short. 0.68. What is the ratio of the Expenses (in $) in Israel in 2002 to that in 2008?
Provide a succinct answer. 0.59. What is the ratio of the Expenses (in $) in San Marino in 2002 to that in 2008?
Provide a succinct answer. 0.48. What is the ratio of the Expenses (in $) in Sri Lanka in 2002 to that in 2008?
Provide a short and direct response. 0.44. What is the ratio of the Expenses (in $) of Congo (Republic) in 2003 to that in 2004?
Give a very brief answer. 1.12. What is the ratio of the Expenses (in $) of Israel in 2003 to that in 2004?
Offer a terse response. 0.87. What is the ratio of the Expenses (in $) in San Marino in 2003 to that in 2004?
Your response must be concise. 0.64. What is the ratio of the Expenses (in $) of Sri Lanka in 2003 to that in 2004?
Offer a terse response. 0.83. What is the ratio of the Expenses (in $) of Congo (Republic) in 2003 to that in 2005?
Offer a terse response. 1.25. What is the ratio of the Expenses (in $) in Israel in 2003 to that in 2005?
Your answer should be very brief. 0.79. What is the ratio of the Expenses (in $) of San Marino in 2003 to that in 2005?
Keep it short and to the point. 0.44. What is the ratio of the Expenses (in $) in Sri Lanka in 2003 to that in 2005?
Your answer should be very brief. 0.75. What is the ratio of the Expenses (in $) of Congo (Republic) in 2003 to that in 2006?
Offer a terse response. 0.97. What is the ratio of the Expenses (in $) in Israel in 2003 to that in 2006?
Provide a succinct answer. 0.74. What is the ratio of the Expenses (in $) in San Marino in 2003 to that in 2006?
Provide a succinct answer. 0.38. What is the ratio of the Expenses (in $) of Sri Lanka in 2003 to that in 2006?
Provide a succinct answer. 0.65. What is the ratio of the Expenses (in $) of Congo (Republic) in 2003 to that in 2007?
Provide a short and direct response. 0.98. What is the ratio of the Expenses (in $) of Israel in 2003 to that in 2007?
Keep it short and to the point. 0.63. What is the ratio of the Expenses (in $) of San Marino in 2003 to that in 2007?
Make the answer very short. 0.42. What is the ratio of the Expenses (in $) in Sri Lanka in 2003 to that in 2007?
Give a very brief answer. 0.61. What is the ratio of the Expenses (in $) in Congo (Republic) in 2003 to that in 2008?
Keep it short and to the point. 0.82. What is the ratio of the Expenses (in $) of Israel in 2003 to that in 2008?
Provide a short and direct response. 0.59. What is the ratio of the Expenses (in $) of San Marino in 2003 to that in 2008?
Ensure brevity in your answer.  0.41. What is the ratio of the Expenses (in $) of Sri Lanka in 2003 to that in 2008?
Keep it short and to the point. 0.54. What is the ratio of the Expenses (in $) of Congo (Republic) in 2004 to that in 2005?
Provide a short and direct response. 1.12. What is the ratio of the Expenses (in $) in Israel in 2004 to that in 2005?
Offer a terse response. 0.91. What is the ratio of the Expenses (in $) of San Marino in 2004 to that in 2005?
Give a very brief answer. 0.7. What is the ratio of the Expenses (in $) of Sri Lanka in 2004 to that in 2005?
Offer a very short reply. 0.91. What is the ratio of the Expenses (in $) in Congo (Republic) in 2004 to that in 2006?
Your response must be concise. 0.87. What is the ratio of the Expenses (in $) in Israel in 2004 to that in 2006?
Your answer should be compact. 0.84. What is the ratio of the Expenses (in $) in San Marino in 2004 to that in 2006?
Your answer should be very brief. 0.59. What is the ratio of the Expenses (in $) in Sri Lanka in 2004 to that in 2006?
Make the answer very short. 0.78. What is the ratio of the Expenses (in $) in Congo (Republic) in 2004 to that in 2007?
Provide a succinct answer. 0.88. What is the ratio of the Expenses (in $) in Israel in 2004 to that in 2007?
Your response must be concise. 0.72. What is the ratio of the Expenses (in $) in San Marino in 2004 to that in 2007?
Ensure brevity in your answer.  0.65. What is the ratio of the Expenses (in $) in Sri Lanka in 2004 to that in 2007?
Keep it short and to the point. 0.73. What is the ratio of the Expenses (in $) of Congo (Republic) in 2004 to that in 2008?
Offer a terse response. 0.74. What is the ratio of the Expenses (in $) in Israel in 2004 to that in 2008?
Your answer should be very brief. 0.67. What is the ratio of the Expenses (in $) in San Marino in 2004 to that in 2008?
Ensure brevity in your answer.  0.65. What is the ratio of the Expenses (in $) in Sri Lanka in 2004 to that in 2008?
Offer a very short reply. 0.64. What is the ratio of the Expenses (in $) in Congo (Republic) in 2005 to that in 2006?
Offer a very short reply. 0.77. What is the ratio of the Expenses (in $) of Israel in 2005 to that in 2006?
Ensure brevity in your answer.  0.93. What is the ratio of the Expenses (in $) of San Marino in 2005 to that in 2006?
Give a very brief answer. 0.85. What is the ratio of the Expenses (in $) of Sri Lanka in 2005 to that in 2006?
Your response must be concise. 0.86. What is the ratio of the Expenses (in $) of Congo (Republic) in 2005 to that in 2007?
Provide a succinct answer. 0.79. What is the ratio of the Expenses (in $) in Israel in 2005 to that in 2007?
Keep it short and to the point. 0.8. What is the ratio of the Expenses (in $) in San Marino in 2005 to that in 2007?
Offer a very short reply. 0.94. What is the ratio of the Expenses (in $) in Sri Lanka in 2005 to that in 2007?
Make the answer very short. 0.81. What is the ratio of the Expenses (in $) of Congo (Republic) in 2005 to that in 2008?
Provide a succinct answer. 0.66. What is the ratio of the Expenses (in $) in Israel in 2005 to that in 2008?
Your answer should be very brief. 0.74. What is the ratio of the Expenses (in $) in San Marino in 2005 to that in 2008?
Provide a succinct answer. 0.93. What is the ratio of the Expenses (in $) of Sri Lanka in 2005 to that in 2008?
Your response must be concise. 0.71. What is the ratio of the Expenses (in $) in Congo (Republic) in 2006 to that in 2007?
Your answer should be very brief. 1.02. What is the ratio of the Expenses (in $) of Israel in 2006 to that in 2007?
Keep it short and to the point. 0.86. What is the ratio of the Expenses (in $) of San Marino in 2006 to that in 2007?
Ensure brevity in your answer.  1.1. What is the ratio of the Expenses (in $) in Sri Lanka in 2006 to that in 2007?
Offer a very short reply. 0.94. What is the ratio of the Expenses (in $) of Congo (Republic) in 2006 to that in 2008?
Give a very brief answer. 0.85. What is the ratio of the Expenses (in $) in Israel in 2006 to that in 2008?
Make the answer very short. 0.8. What is the ratio of the Expenses (in $) in San Marino in 2006 to that in 2008?
Ensure brevity in your answer.  1.1. What is the ratio of the Expenses (in $) in Sri Lanka in 2006 to that in 2008?
Ensure brevity in your answer.  0.82. What is the ratio of the Expenses (in $) of Congo (Republic) in 2007 to that in 2008?
Make the answer very short. 0.84. What is the ratio of the Expenses (in $) in Israel in 2007 to that in 2008?
Your answer should be very brief. 0.93. What is the ratio of the Expenses (in $) of Sri Lanka in 2007 to that in 2008?
Offer a terse response. 0.88. What is the difference between the highest and the second highest Expenses (in $) of Congo (Republic)?
Give a very brief answer. 7.95e+09. What is the difference between the highest and the second highest Expenses (in $) of Israel?
Your answer should be very brief. 1.60e+08. What is the difference between the highest and the second highest Expenses (in $) in San Marino?
Give a very brief answer. 8.89e+05. What is the difference between the highest and the second highest Expenses (in $) of Sri Lanka?
Your answer should be very brief. 7.86e+09. What is the difference between the highest and the lowest Expenses (in $) in Congo (Republic)?
Make the answer very short. 1.81e+1. What is the difference between the highest and the lowest Expenses (in $) of Israel?
Keep it short and to the point. 9.81e+08. What is the difference between the highest and the lowest Expenses (in $) in San Marino?
Give a very brief answer. 6.27e+06. What is the difference between the highest and the lowest Expenses (in $) in Sri Lanka?
Provide a short and direct response. 3.55e+1. 